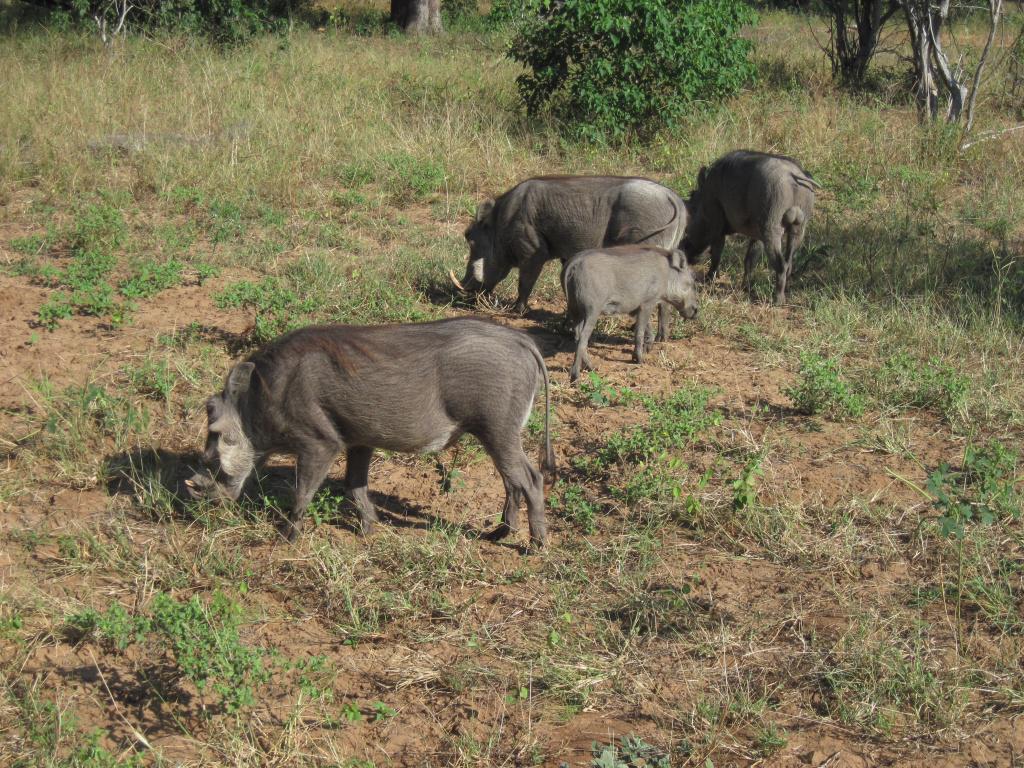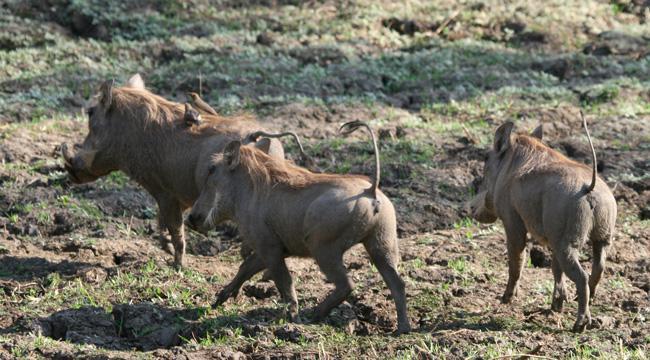The first image is the image on the left, the second image is the image on the right. Considering the images on both sides, is "An image shows a warthog sitting upright, with multiple hogs behind it." valid? Answer yes or no. No. 